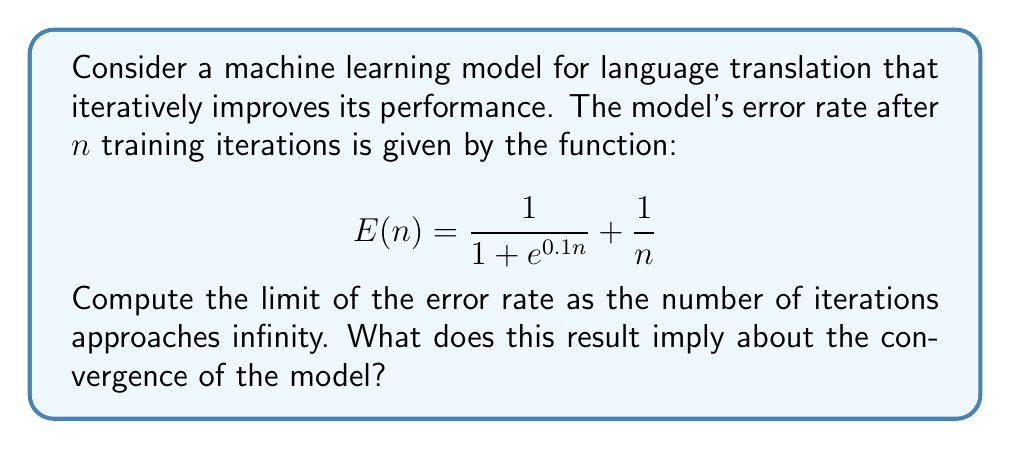Give your solution to this math problem. To solve this problem, we need to evaluate the limit of E(n) as n approaches infinity. Let's break it down step by step:

1. First, let's consider the limit of each term separately:

   a) For the first term: $\lim_{n \to \infty} \frac{1}{1 + e^{0.1n}}$
      As n approaches infinity, $e^{0.1n}$ grows exponentially, so:
      $$\lim_{n \to \infty} \frac{1}{1 + e^{0.1n}} = 0$$

   b) For the second term: $\lim_{n \to \infty} \frac{1}{n} = 0$

2. Now, we can apply the limit sum rule:
   $$\lim_{n \to \infty} E(n) = \lim_{n \to \infty} (\frac{1}{1 + e^{0.1n}} + \frac{1}{n})$$
   $$= \lim_{n \to \infty} \frac{1}{1 + e^{0.1n}} + \lim_{n \to \infty} \frac{1}{n}$$
   $$= 0 + 0 = 0$$

3. Therefore, the limit of the error rate as the number of iterations approaches infinity is 0.

This result implies that the machine learning model for language translation converges to a perfect translation (zero error) as the number of training iterations increases indefinitely. In practice, however, achieving zero error is often impossible due to various factors such as the complexity of natural language and limitations of the model architecture.

For a language software developer, this mathematical analysis provides insight into the theoretical behavior of the model. It suggests that with sufficient training, the model can achieve arbitrarily low error rates, which is valuable information for algorithm development and performance expectations.
Answer: The limit of the error rate as the number of iterations approaches infinity is 0, implying that the model theoretically converges to perfect translation with infinite training iterations. 